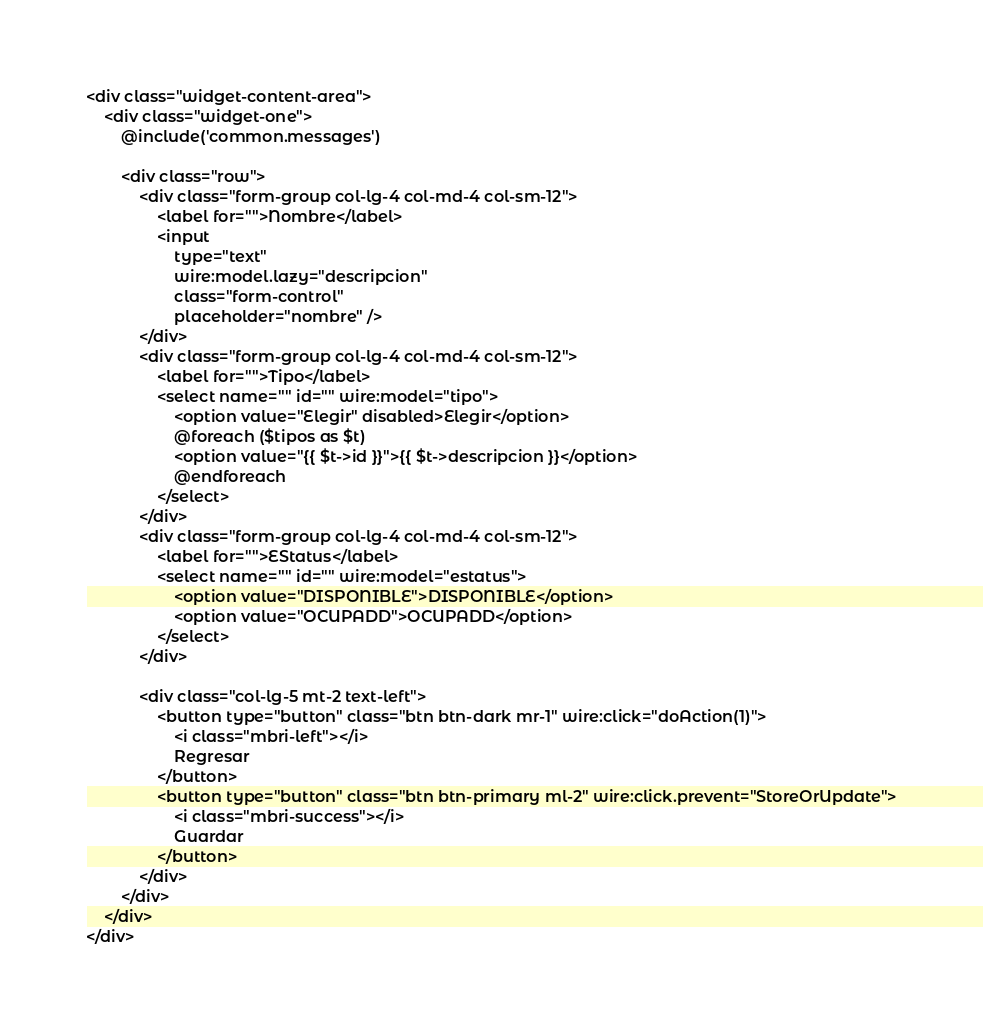Convert code to text. <code><loc_0><loc_0><loc_500><loc_500><_PHP_><div class="widget-content-area">
    <div class="widget-one">
        @include('common.messages')

        <div class="row">
            <div class="form-group col-lg-4 col-md-4 col-sm-12">
                <label for="">Nombre</label>
                <input 
                    type="text" 
                    wire:model.lazy="descripcion" 
                    class="form-control" 
                    placeholder="nombre" />
            </div>
            <div class="form-group col-lg-4 col-md-4 col-sm-12">
                <label for="">Tipo</label>
                <select name="" id="" wire:model="tipo">
                    <option value="Elegir" disabled>Elegir</option>
                    @foreach ($tipos as $t)
                    <option value="{{ $t->id }}">{{ $t->descripcion }}</option>
                    @endforeach
                </select>
            </div>
            <div class="form-group col-lg-4 col-md-4 col-sm-12">
                <label for="">EStatus</label>
                <select name="" id="" wire:model="estatus">
                    <option value="DISPONIBLE">DISPONIBLE</option>
                    <option value="OCUPADD">OCUPADD</option>
                </select>
            </div>

            <div class="col-lg-5 mt-2 text-left">
                <button type="button" class="btn btn-dark mr-1" wire:click="doAction(1)">
                    <i class="mbri-left"></i> 
                    Regresar
                </button>
                <button type="button" class="btn btn-primary ml-2" wire:click.prevent="StoreOrUpdate">
                    <i class="mbri-success"></i> 
                    Guardar
                </button>
            </div>
        </div>
    </div>
</div></code> 